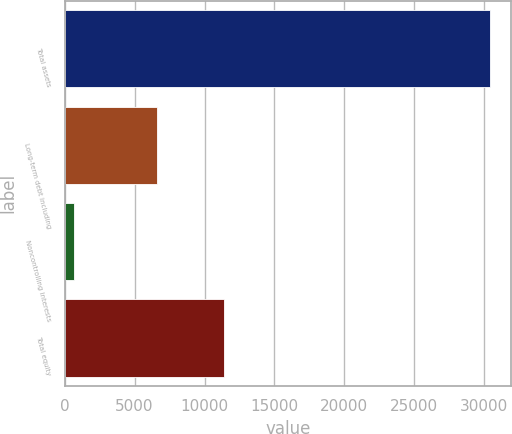Convert chart to OTSL. <chart><loc_0><loc_0><loc_500><loc_500><bar_chart><fcel>Total assets<fcel>Long-term debt including<fcel>Noncontrolling interests<fcel>Total equity<nl><fcel>30425<fcel>6602<fcel>639<fcel>11390<nl></chart> 